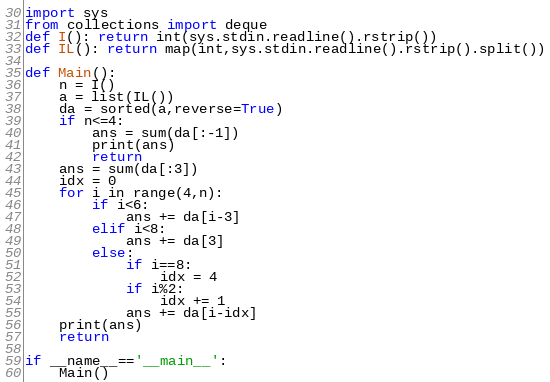Convert code to text. <code><loc_0><loc_0><loc_500><loc_500><_Python_>import sys
from collections import deque
def I(): return int(sys.stdin.readline().rstrip())
def IL(): return map(int,sys.stdin.readline().rstrip().split())

def Main():
    n = I()
    a = list(IL())
    da = sorted(a,reverse=True)
    if n<=4:
        ans = sum(da[:-1])
        print(ans)
        return
    ans = sum(da[:3])
    idx = 0
    for i in range(4,n):
        if i<6:
            ans += da[i-3]
        elif i<8:
            ans += da[3]
        else:
            if i==8:
                idx = 4
            if i%2:
                idx += 1
            ans += da[i-idx]
    print(ans)
    return

if __name__=='__main__':
    Main()</code> 